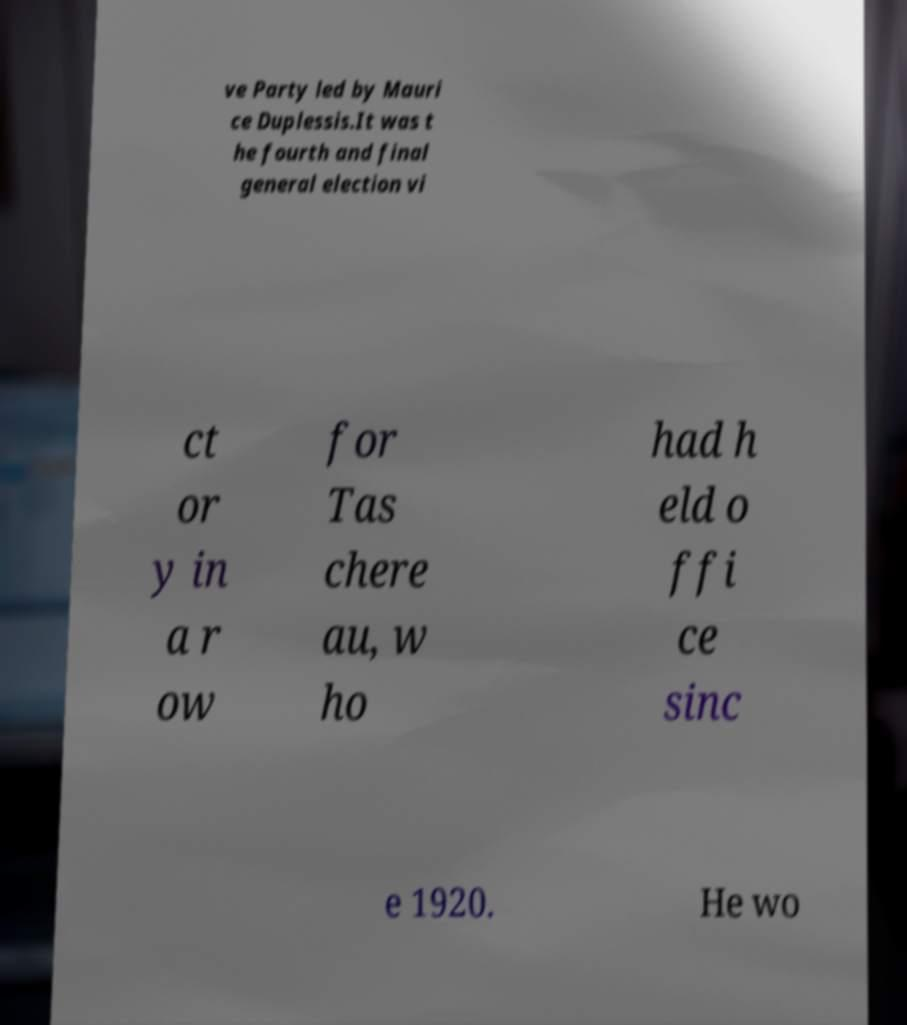Could you assist in decoding the text presented in this image and type it out clearly? ve Party led by Mauri ce Duplessis.It was t he fourth and final general election vi ct or y in a r ow for Tas chere au, w ho had h eld o ffi ce sinc e 1920. He wo 